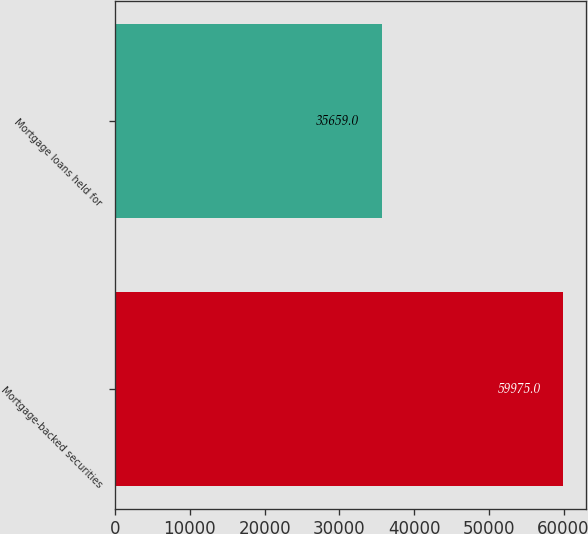<chart> <loc_0><loc_0><loc_500><loc_500><bar_chart><fcel>Mortgage-backed securities<fcel>Mortgage loans held for<nl><fcel>59975<fcel>35659<nl></chart> 